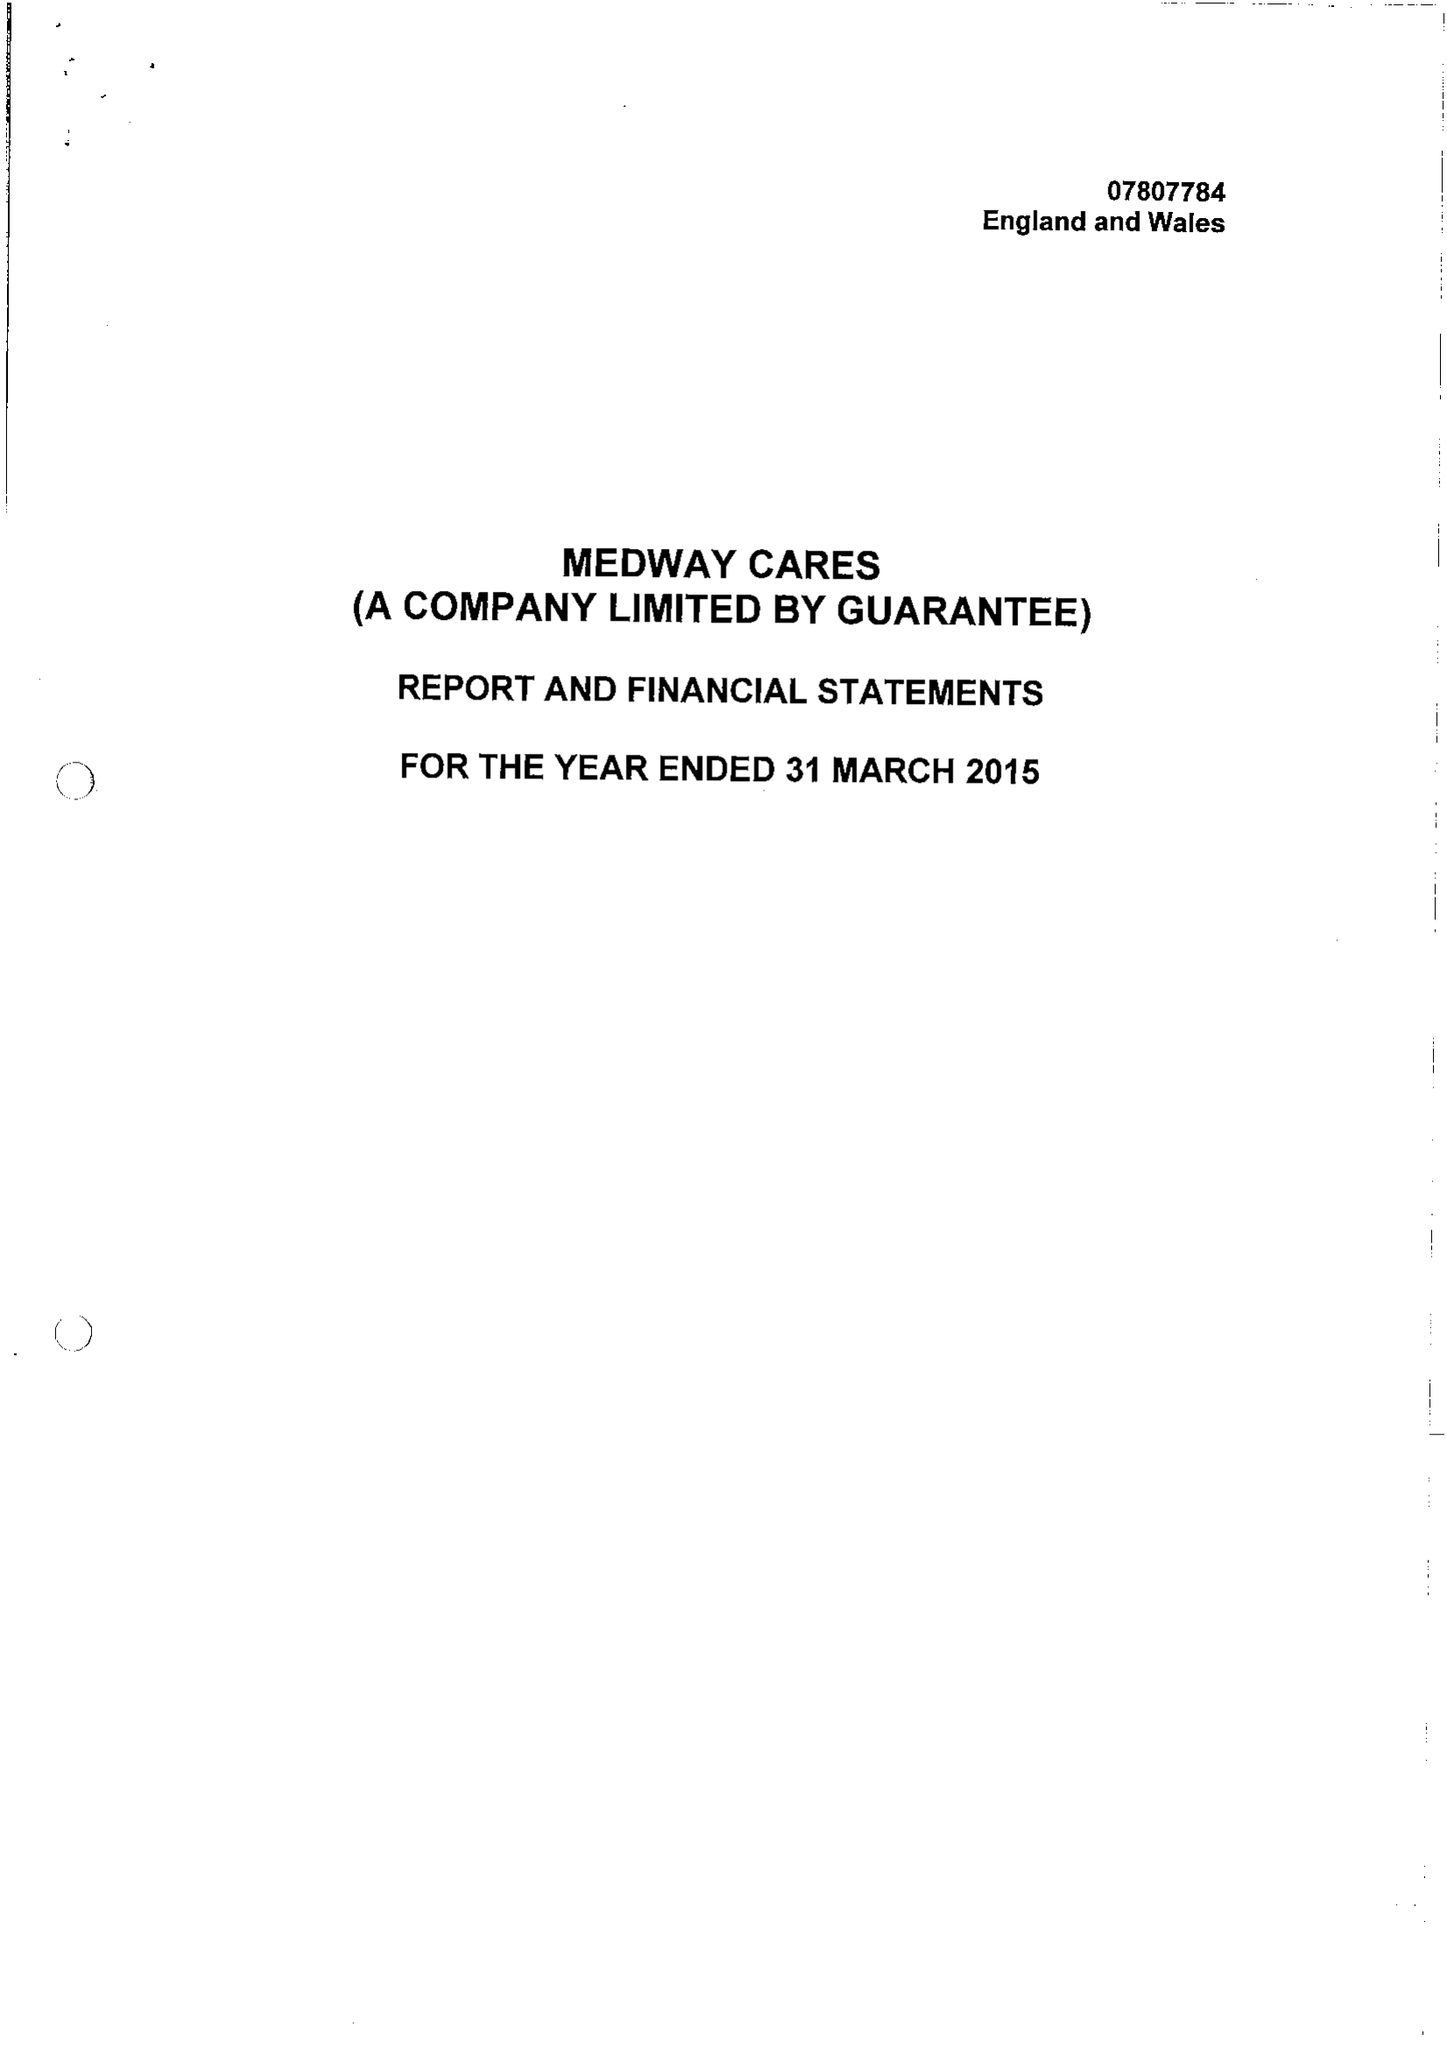What is the value for the charity_number?
Answer the question using a single word or phrase. 1145540 